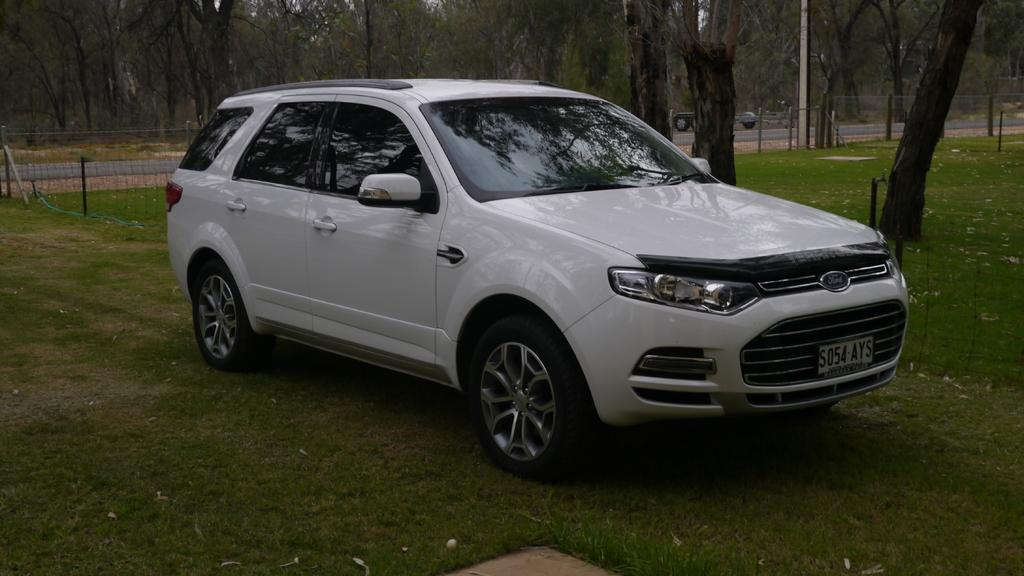What color is the car in the image? The car in the image is white. What type of terrain is visible at the bottom of the image? There is grass at the bottom of the image. What can be seen in the background of the image? There are trees in the background of the image. What type of barrier is present in the image? There is fencing in the image. What type of brass instrument is being played in the image? There is no brass instrument or any indication of music being played in the image. 